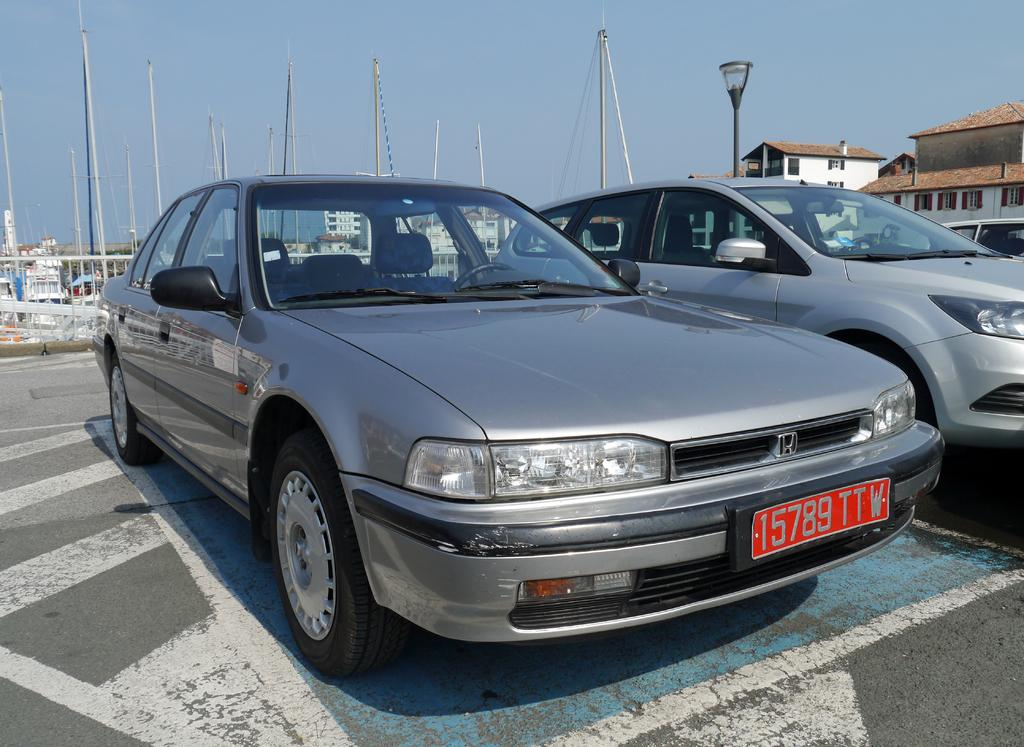What type of vehicles can be seen on the road in the image? There are cars on the road in the image. What structures are present in the image besides the cars? There are poles and buildings with windows in the image. What can be seen in the background of the image? The sky is visible in the background of the image. What type of butter is being used to grease the pot in the image? There is no butter or pot present in the image; it only features cars on the road, poles, buildings with windows, and the sky in the background. 